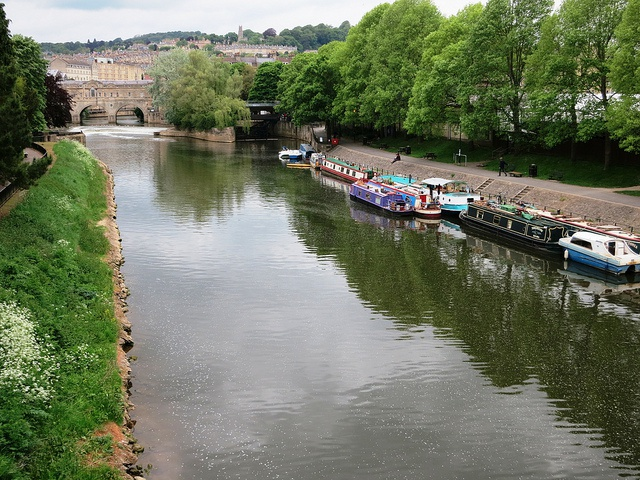Describe the objects in this image and their specific colors. I can see boat in lightgray, black, gray, and darkgray tones, boat in lightgray, white, black, darkgray, and gray tones, boat in lightgray, black, darkgray, and cyan tones, boat in lightgray, black, blue, gray, and lavender tones, and boat in lightgray, white, brown, gray, and darkgray tones in this image. 